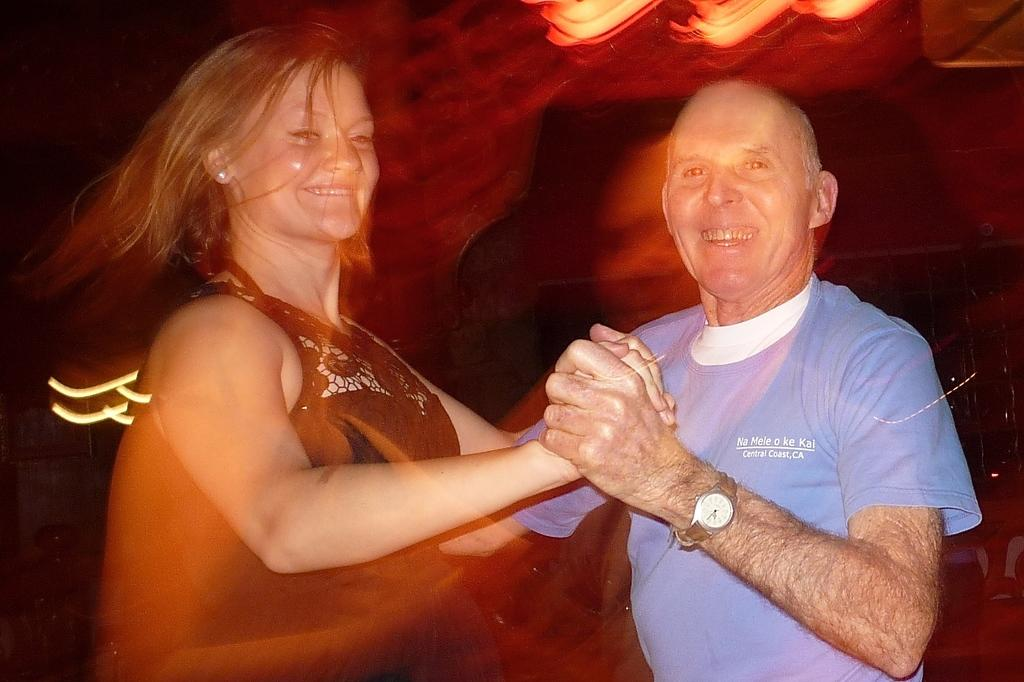Who are the people in the image? There is a lady and an old man in the image. What are they doing in the image? They are dancing. Can you describe the man's attire? The man is wearing a blue t-shirt and a watch. How are the people in the image feeling? Both the lady and the old man are smiling. What can be said about the background of the image? The background of the image is hazy. Can you see any bats flying in the field in the image? There is no field or bats present in the image; it features a lady and an old man dancing with a hazy background. 